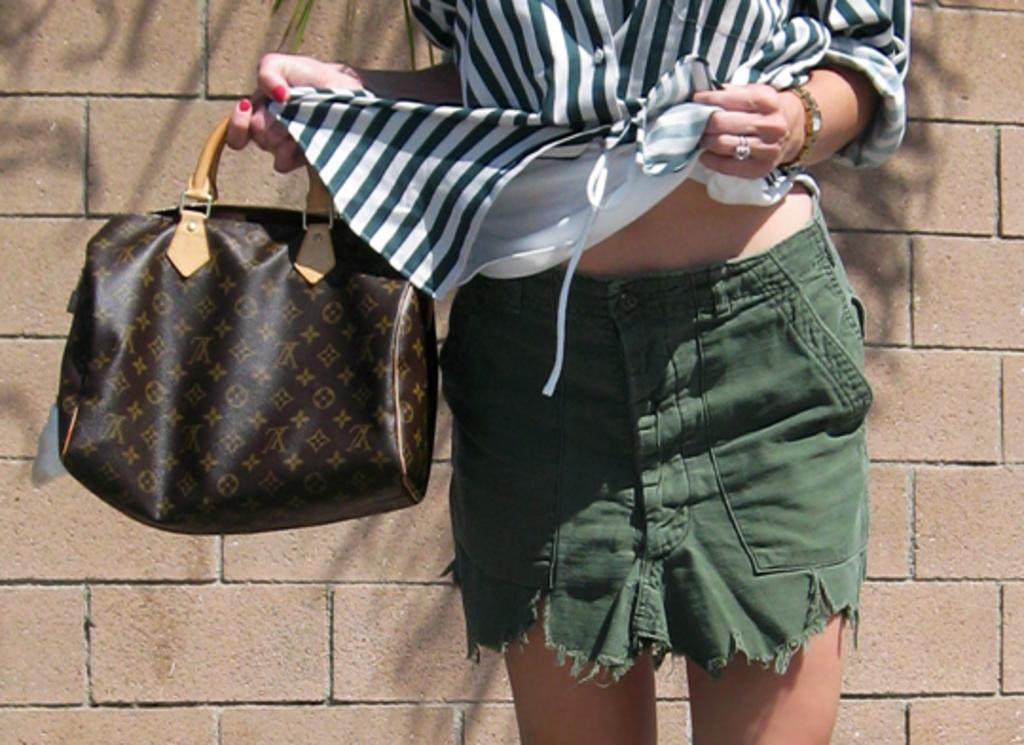Please provide a concise description of this image. In this image I can see a person standing and the person is wearing black and white shirt and green color short. The person is holding a bag which is in brown color, background the wall is in brown color. 